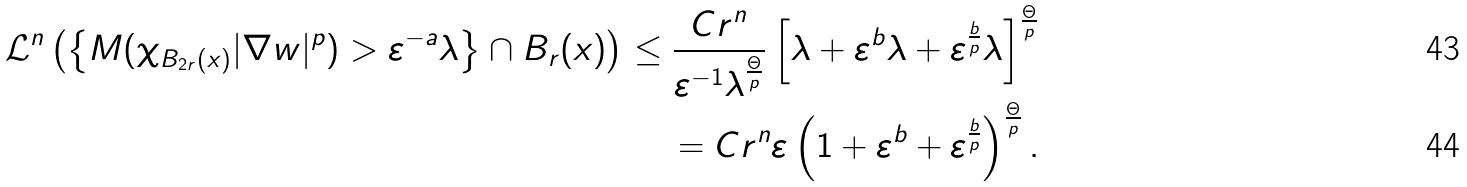<formula> <loc_0><loc_0><loc_500><loc_500>\mathcal { L } ^ { n } \left ( \left \{ { M } ( \chi _ { B _ { 2 r } ( x ) } | \nabla w | ^ { p } ) > \varepsilon ^ { - a } \lambda \right \} \cap B _ { r } ( x ) \right ) \leq \frac { C r ^ { n } } { \varepsilon ^ { - 1 } \lambda ^ { \frac { \Theta } { p } } } \left [ \lambda + \varepsilon ^ { b } \lambda + \varepsilon ^ { \frac { b } { p } } \lambda \right ] ^ { \frac { \Theta } { p } } \\ = { C r ^ { n } } { \varepsilon } \left ( 1 + \varepsilon ^ { b } + \varepsilon ^ { \frac { b } { p } } \right ) ^ { \frac { \Theta } { p } } .</formula> 